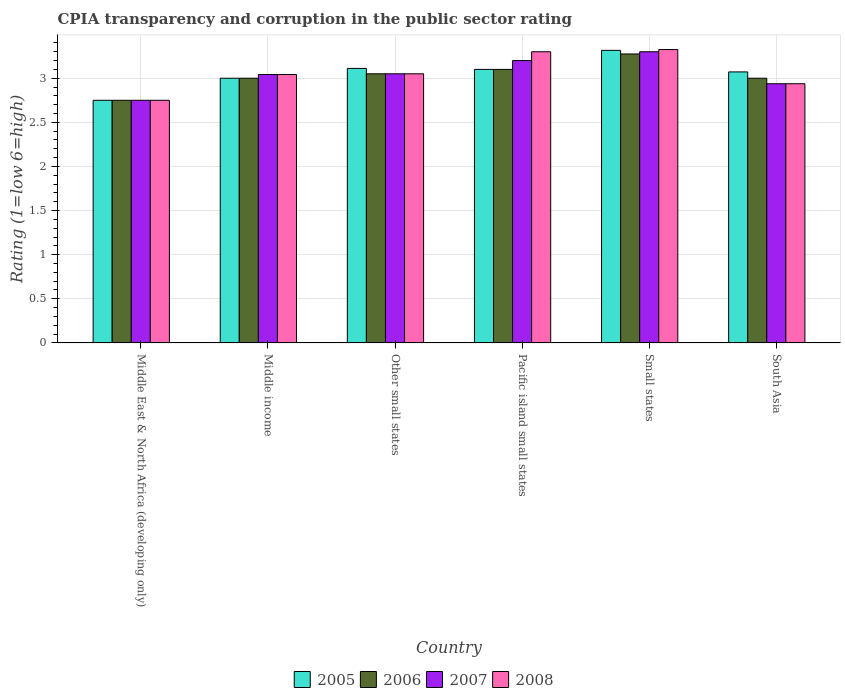Are the number of bars on each tick of the X-axis equal?
Offer a terse response. Yes. How many bars are there on the 6th tick from the left?
Your answer should be compact. 4. What is the label of the 5th group of bars from the left?
Offer a terse response. Small states. In how many cases, is the number of bars for a given country not equal to the number of legend labels?
Give a very brief answer. 0. What is the CPIA rating in 2005 in Other small states?
Your response must be concise. 3.11. Across all countries, what is the maximum CPIA rating in 2008?
Your response must be concise. 3.33. Across all countries, what is the minimum CPIA rating in 2008?
Ensure brevity in your answer.  2.75. In which country was the CPIA rating in 2007 maximum?
Your answer should be very brief. Small states. In which country was the CPIA rating in 2008 minimum?
Offer a terse response. Middle East & North Africa (developing only). What is the total CPIA rating in 2005 in the graph?
Your answer should be compact. 18.35. What is the difference between the CPIA rating in 2007 in Small states and that in South Asia?
Ensure brevity in your answer.  0.36. What is the difference between the CPIA rating in 2008 in Middle East & North Africa (developing only) and the CPIA rating in 2007 in Other small states?
Your answer should be compact. -0.3. What is the average CPIA rating in 2005 per country?
Your response must be concise. 3.06. What is the difference between the CPIA rating of/in 2007 and CPIA rating of/in 2008 in Small states?
Offer a very short reply. -0.03. In how many countries, is the CPIA rating in 2008 greater than 1.7?
Your response must be concise. 6. What is the ratio of the CPIA rating in 2006 in Middle East & North Africa (developing only) to that in South Asia?
Make the answer very short. 0.92. What is the difference between the highest and the second highest CPIA rating in 2007?
Provide a succinct answer. -0.1. What is the difference between the highest and the lowest CPIA rating in 2005?
Your answer should be compact. 0.57. In how many countries, is the CPIA rating in 2007 greater than the average CPIA rating in 2007 taken over all countries?
Provide a succinct answer. 3. Is the sum of the CPIA rating in 2008 in Pacific island small states and South Asia greater than the maximum CPIA rating in 2007 across all countries?
Your response must be concise. Yes. Is it the case that in every country, the sum of the CPIA rating in 2006 and CPIA rating in 2005 is greater than the sum of CPIA rating in 2007 and CPIA rating in 2008?
Your response must be concise. No. What does the 3rd bar from the left in Pacific island small states represents?
Your answer should be very brief. 2007. Is it the case that in every country, the sum of the CPIA rating in 2006 and CPIA rating in 2005 is greater than the CPIA rating in 2008?
Provide a succinct answer. Yes. How many bars are there?
Provide a short and direct response. 24. Are all the bars in the graph horizontal?
Make the answer very short. No. Does the graph contain grids?
Keep it short and to the point. Yes. Where does the legend appear in the graph?
Your response must be concise. Bottom center. What is the title of the graph?
Give a very brief answer. CPIA transparency and corruption in the public sector rating. Does "2003" appear as one of the legend labels in the graph?
Offer a terse response. No. What is the label or title of the X-axis?
Provide a short and direct response. Country. What is the Rating (1=low 6=high) of 2005 in Middle East & North Africa (developing only)?
Offer a terse response. 2.75. What is the Rating (1=low 6=high) of 2006 in Middle East & North Africa (developing only)?
Provide a short and direct response. 2.75. What is the Rating (1=low 6=high) in 2007 in Middle East & North Africa (developing only)?
Your answer should be compact. 2.75. What is the Rating (1=low 6=high) in 2008 in Middle East & North Africa (developing only)?
Provide a succinct answer. 2.75. What is the Rating (1=low 6=high) of 2005 in Middle income?
Provide a short and direct response. 3. What is the Rating (1=low 6=high) in 2007 in Middle income?
Keep it short and to the point. 3.04. What is the Rating (1=low 6=high) in 2008 in Middle income?
Keep it short and to the point. 3.04. What is the Rating (1=low 6=high) in 2005 in Other small states?
Your answer should be compact. 3.11. What is the Rating (1=low 6=high) of 2006 in Other small states?
Ensure brevity in your answer.  3.05. What is the Rating (1=low 6=high) in 2007 in Other small states?
Give a very brief answer. 3.05. What is the Rating (1=low 6=high) of 2008 in Other small states?
Keep it short and to the point. 3.05. What is the Rating (1=low 6=high) in 2006 in Pacific island small states?
Make the answer very short. 3.1. What is the Rating (1=low 6=high) of 2007 in Pacific island small states?
Provide a succinct answer. 3.2. What is the Rating (1=low 6=high) of 2008 in Pacific island small states?
Your answer should be very brief. 3.3. What is the Rating (1=low 6=high) in 2005 in Small states?
Your answer should be compact. 3.32. What is the Rating (1=low 6=high) in 2006 in Small states?
Provide a succinct answer. 3.27. What is the Rating (1=low 6=high) in 2008 in Small states?
Offer a terse response. 3.33. What is the Rating (1=low 6=high) of 2005 in South Asia?
Provide a succinct answer. 3.07. What is the Rating (1=low 6=high) in 2006 in South Asia?
Offer a very short reply. 3. What is the Rating (1=low 6=high) in 2007 in South Asia?
Provide a short and direct response. 2.94. What is the Rating (1=low 6=high) in 2008 in South Asia?
Ensure brevity in your answer.  2.94. Across all countries, what is the maximum Rating (1=low 6=high) of 2005?
Your response must be concise. 3.32. Across all countries, what is the maximum Rating (1=low 6=high) of 2006?
Your answer should be very brief. 3.27. Across all countries, what is the maximum Rating (1=low 6=high) of 2007?
Provide a succinct answer. 3.3. Across all countries, what is the maximum Rating (1=low 6=high) in 2008?
Offer a terse response. 3.33. Across all countries, what is the minimum Rating (1=low 6=high) in 2005?
Offer a terse response. 2.75. Across all countries, what is the minimum Rating (1=low 6=high) in 2006?
Provide a short and direct response. 2.75. Across all countries, what is the minimum Rating (1=low 6=high) of 2007?
Your response must be concise. 2.75. Across all countries, what is the minimum Rating (1=low 6=high) of 2008?
Provide a short and direct response. 2.75. What is the total Rating (1=low 6=high) of 2005 in the graph?
Your answer should be compact. 18.35. What is the total Rating (1=low 6=high) in 2006 in the graph?
Offer a very short reply. 18.18. What is the total Rating (1=low 6=high) of 2007 in the graph?
Your response must be concise. 18.28. What is the total Rating (1=low 6=high) of 2008 in the graph?
Ensure brevity in your answer.  18.4. What is the difference between the Rating (1=low 6=high) in 2007 in Middle East & North Africa (developing only) and that in Middle income?
Make the answer very short. -0.29. What is the difference between the Rating (1=low 6=high) in 2008 in Middle East & North Africa (developing only) and that in Middle income?
Your answer should be compact. -0.29. What is the difference between the Rating (1=low 6=high) of 2005 in Middle East & North Africa (developing only) and that in Other small states?
Provide a succinct answer. -0.36. What is the difference between the Rating (1=low 6=high) in 2006 in Middle East & North Africa (developing only) and that in Other small states?
Provide a short and direct response. -0.3. What is the difference between the Rating (1=low 6=high) of 2008 in Middle East & North Africa (developing only) and that in Other small states?
Make the answer very short. -0.3. What is the difference between the Rating (1=low 6=high) in 2005 in Middle East & North Africa (developing only) and that in Pacific island small states?
Give a very brief answer. -0.35. What is the difference between the Rating (1=low 6=high) of 2006 in Middle East & North Africa (developing only) and that in Pacific island small states?
Your answer should be compact. -0.35. What is the difference between the Rating (1=low 6=high) in 2007 in Middle East & North Africa (developing only) and that in Pacific island small states?
Give a very brief answer. -0.45. What is the difference between the Rating (1=low 6=high) in 2008 in Middle East & North Africa (developing only) and that in Pacific island small states?
Provide a succinct answer. -0.55. What is the difference between the Rating (1=low 6=high) of 2005 in Middle East & North Africa (developing only) and that in Small states?
Your response must be concise. -0.57. What is the difference between the Rating (1=low 6=high) in 2006 in Middle East & North Africa (developing only) and that in Small states?
Make the answer very short. -0.53. What is the difference between the Rating (1=low 6=high) of 2007 in Middle East & North Africa (developing only) and that in Small states?
Ensure brevity in your answer.  -0.55. What is the difference between the Rating (1=low 6=high) of 2008 in Middle East & North Africa (developing only) and that in Small states?
Your answer should be compact. -0.57. What is the difference between the Rating (1=low 6=high) in 2005 in Middle East & North Africa (developing only) and that in South Asia?
Your answer should be very brief. -0.32. What is the difference between the Rating (1=low 6=high) of 2007 in Middle East & North Africa (developing only) and that in South Asia?
Give a very brief answer. -0.19. What is the difference between the Rating (1=low 6=high) in 2008 in Middle East & North Africa (developing only) and that in South Asia?
Ensure brevity in your answer.  -0.19. What is the difference between the Rating (1=low 6=high) in 2005 in Middle income and that in Other small states?
Your answer should be compact. -0.11. What is the difference between the Rating (1=low 6=high) of 2006 in Middle income and that in Other small states?
Your answer should be very brief. -0.05. What is the difference between the Rating (1=low 6=high) in 2007 in Middle income and that in Other small states?
Ensure brevity in your answer.  -0.01. What is the difference between the Rating (1=low 6=high) in 2008 in Middle income and that in Other small states?
Your answer should be very brief. -0.01. What is the difference between the Rating (1=low 6=high) of 2005 in Middle income and that in Pacific island small states?
Provide a succinct answer. -0.1. What is the difference between the Rating (1=low 6=high) in 2006 in Middle income and that in Pacific island small states?
Provide a short and direct response. -0.1. What is the difference between the Rating (1=low 6=high) in 2007 in Middle income and that in Pacific island small states?
Offer a terse response. -0.16. What is the difference between the Rating (1=low 6=high) of 2008 in Middle income and that in Pacific island small states?
Provide a short and direct response. -0.26. What is the difference between the Rating (1=low 6=high) of 2005 in Middle income and that in Small states?
Provide a succinct answer. -0.32. What is the difference between the Rating (1=low 6=high) of 2006 in Middle income and that in Small states?
Give a very brief answer. -0.28. What is the difference between the Rating (1=low 6=high) of 2007 in Middle income and that in Small states?
Provide a succinct answer. -0.26. What is the difference between the Rating (1=low 6=high) in 2008 in Middle income and that in Small states?
Provide a short and direct response. -0.28. What is the difference between the Rating (1=low 6=high) of 2005 in Middle income and that in South Asia?
Provide a short and direct response. -0.07. What is the difference between the Rating (1=low 6=high) in 2007 in Middle income and that in South Asia?
Keep it short and to the point. 0.1. What is the difference between the Rating (1=low 6=high) of 2008 in Middle income and that in South Asia?
Keep it short and to the point. 0.1. What is the difference between the Rating (1=low 6=high) of 2005 in Other small states and that in Pacific island small states?
Ensure brevity in your answer.  0.01. What is the difference between the Rating (1=low 6=high) in 2005 in Other small states and that in Small states?
Keep it short and to the point. -0.2. What is the difference between the Rating (1=low 6=high) of 2006 in Other small states and that in Small states?
Provide a short and direct response. -0.23. What is the difference between the Rating (1=low 6=high) in 2007 in Other small states and that in Small states?
Your answer should be compact. -0.25. What is the difference between the Rating (1=low 6=high) in 2008 in Other small states and that in Small states?
Your response must be concise. -0.28. What is the difference between the Rating (1=low 6=high) of 2005 in Other small states and that in South Asia?
Make the answer very short. 0.04. What is the difference between the Rating (1=low 6=high) in 2007 in Other small states and that in South Asia?
Provide a short and direct response. 0.11. What is the difference between the Rating (1=low 6=high) in 2008 in Other small states and that in South Asia?
Give a very brief answer. 0.11. What is the difference between the Rating (1=low 6=high) of 2005 in Pacific island small states and that in Small states?
Give a very brief answer. -0.22. What is the difference between the Rating (1=low 6=high) of 2006 in Pacific island small states and that in Small states?
Give a very brief answer. -0.17. What is the difference between the Rating (1=low 6=high) of 2007 in Pacific island small states and that in Small states?
Make the answer very short. -0.1. What is the difference between the Rating (1=low 6=high) in 2008 in Pacific island small states and that in Small states?
Keep it short and to the point. -0.03. What is the difference between the Rating (1=low 6=high) of 2005 in Pacific island small states and that in South Asia?
Offer a very short reply. 0.03. What is the difference between the Rating (1=low 6=high) in 2007 in Pacific island small states and that in South Asia?
Ensure brevity in your answer.  0.26. What is the difference between the Rating (1=low 6=high) in 2008 in Pacific island small states and that in South Asia?
Offer a terse response. 0.36. What is the difference between the Rating (1=low 6=high) of 2005 in Small states and that in South Asia?
Ensure brevity in your answer.  0.24. What is the difference between the Rating (1=low 6=high) of 2006 in Small states and that in South Asia?
Your answer should be very brief. 0.28. What is the difference between the Rating (1=low 6=high) in 2007 in Small states and that in South Asia?
Keep it short and to the point. 0.36. What is the difference between the Rating (1=low 6=high) in 2008 in Small states and that in South Asia?
Your answer should be very brief. 0.39. What is the difference between the Rating (1=low 6=high) of 2005 in Middle East & North Africa (developing only) and the Rating (1=low 6=high) of 2006 in Middle income?
Your response must be concise. -0.25. What is the difference between the Rating (1=low 6=high) of 2005 in Middle East & North Africa (developing only) and the Rating (1=low 6=high) of 2007 in Middle income?
Make the answer very short. -0.29. What is the difference between the Rating (1=low 6=high) of 2005 in Middle East & North Africa (developing only) and the Rating (1=low 6=high) of 2008 in Middle income?
Your answer should be very brief. -0.29. What is the difference between the Rating (1=low 6=high) in 2006 in Middle East & North Africa (developing only) and the Rating (1=low 6=high) in 2007 in Middle income?
Offer a very short reply. -0.29. What is the difference between the Rating (1=low 6=high) of 2006 in Middle East & North Africa (developing only) and the Rating (1=low 6=high) of 2008 in Middle income?
Offer a terse response. -0.29. What is the difference between the Rating (1=low 6=high) in 2007 in Middle East & North Africa (developing only) and the Rating (1=low 6=high) in 2008 in Middle income?
Give a very brief answer. -0.29. What is the difference between the Rating (1=low 6=high) of 2005 in Middle East & North Africa (developing only) and the Rating (1=low 6=high) of 2008 in Other small states?
Provide a short and direct response. -0.3. What is the difference between the Rating (1=low 6=high) in 2006 in Middle East & North Africa (developing only) and the Rating (1=low 6=high) in 2007 in Other small states?
Your response must be concise. -0.3. What is the difference between the Rating (1=low 6=high) of 2005 in Middle East & North Africa (developing only) and the Rating (1=low 6=high) of 2006 in Pacific island small states?
Make the answer very short. -0.35. What is the difference between the Rating (1=low 6=high) in 2005 in Middle East & North Africa (developing only) and the Rating (1=low 6=high) in 2007 in Pacific island small states?
Keep it short and to the point. -0.45. What is the difference between the Rating (1=low 6=high) in 2005 in Middle East & North Africa (developing only) and the Rating (1=low 6=high) in 2008 in Pacific island small states?
Keep it short and to the point. -0.55. What is the difference between the Rating (1=low 6=high) of 2006 in Middle East & North Africa (developing only) and the Rating (1=low 6=high) of 2007 in Pacific island small states?
Offer a terse response. -0.45. What is the difference between the Rating (1=low 6=high) of 2006 in Middle East & North Africa (developing only) and the Rating (1=low 6=high) of 2008 in Pacific island small states?
Your response must be concise. -0.55. What is the difference between the Rating (1=low 6=high) of 2007 in Middle East & North Africa (developing only) and the Rating (1=low 6=high) of 2008 in Pacific island small states?
Your answer should be very brief. -0.55. What is the difference between the Rating (1=low 6=high) in 2005 in Middle East & North Africa (developing only) and the Rating (1=low 6=high) in 2006 in Small states?
Make the answer very short. -0.53. What is the difference between the Rating (1=low 6=high) in 2005 in Middle East & North Africa (developing only) and the Rating (1=low 6=high) in 2007 in Small states?
Offer a very short reply. -0.55. What is the difference between the Rating (1=low 6=high) of 2005 in Middle East & North Africa (developing only) and the Rating (1=low 6=high) of 2008 in Small states?
Offer a terse response. -0.57. What is the difference between the Rating (1=low 6=high) in 2006 in Middle East & North Africa (developing only) and the Rating (1=low 6=high) in 2007 in Small states?
Provide a succinct answer. -0.55. What is the difference between the Rating (1=low 6=high) of 2006 in Middle East & North Africa (developing only) and the Rating (1=low 6=high) of 2008 in Small states?
Offer a very short reply. -0.57. What is the difference between the Rating (1=low 6=high) in 2007 in Middle East & North Africa (developing only) and the Rating (1=low 6=high) in 2008 in Small states?
Provide a short and direct response. -0.57. What is the difference between the Rating (1=low 6=high) in 2005 in Middle East & North Africa (developing only) and the Rating (1=low 6=high) in 2006 in South Asia?
Provide a short and direct response. -0.25. What is the difference between the Rating (1=low 6=high) of 2005 in Middle East & North Africa (developing only) and the Rating (1=low 6=high) of 2007 in South Asia?
Your answer should be compact. -0.19. What is the difference between the Rating (1=low 6=high) of 2005 in Middle East & North Africa (developing only) and the Rating (1=low 6=high) of 2008 in South Asia?
Offer a terse response. -0.19. What is the difference between the Rating (1=low 6=high) in 2006 in Middle East & North Africa (developing only) and the Rating (1=low 6=high) in 2007 in South Asia?
Offer a terse response. -0.19. What is the difference between the Rating (1=low 6=high) in 2006 in Middle East & North Africa (developing only) and the Rating (1=low 6=high) in 2008 in South Asia?
Your answer should be very brief. -0.19. What is the difference between the Rating (1=low 6=high) of 2007 in Middle East & North Africa (developing only) and the Rating (1=low 6=high) of 2008 in South Asia?
Make the answer very short. -0.19. What is the difference between the Rating (1=low 6=high) of 2005 in Middle income and the Rating (1=low 6=high) of 2007 in Other small states?
Make the answer very short. -0.05. What is the difference between the Rating (1=low 6=high) in 2005 in Middle income and the Rating (1=low 6=high) in 2008 in Other small states?
Offer a very short reply. -0.05. What is the difference between the Rating (1=low 6=high) of 2006 in Middle income and the Rating (1=low 6=high) of 2007 in Other small states?
Your answer should be compact. -0.05. What is the difference between the Rating (1=low 6=high) of 2007 in Middle income and the Rating (1=low 6=high) of 2008 in Other small states?
Ensure brevity in your answer.  -0.01. What is the difference between the Rating (1=low 6=high) of 2007 in Middle income and the Rating (1=low 6=high) of 2008 in Pacific island small states?
Make the answer very short. -0.26. What is the difference between the Rating (1=low 6=high) of 2005 in Middle income and the Rating (1=low 6=high) of 2006 in Small states?
Make the answer very short. -0.28. What is the difference between the Rating (1=low 6=high) in 2005 in Middle income and the Rating (1=low 6=high) in 2008 in Small states?
Provide a succinct answer. -0.33. What is the difference between the Rating (1=low 6=high) of 2006 in Middle income and the Rating (1=low 6=high) of 2007 in Small states?
Your response must be concise. -0.3. What is the difference between the Rating (1=low 6=high) of 2006 in Middle income and the Rating (1=low 6=high) of 2008 in Small states?
Provide a succinct answer. -0.33. What is the difference between the Rating (1=low 6=high) of 2007 in Middle income and the Rating (1=low 6=high) of 2008 in Small states?
Provide a succinct answer. -0.28. What is the difference between the Rating (1=low 6=high) of 2005 in Middle income and the Rating (1=low 6=high) of 2007 in South Asia?
Give a very brief answer. 0.06. What is the difference between the Rating (1=low 6=high) in 2005 in Middle income and the Rating (1=low 6=high) in 2008 in South Asia?
Keep it short and to the point. 0.06. What is the difference between the Rating (1=low 6=high) of 2006 in Middle income and the Rating (1=low 6=high) of 2007 in South Asia?
Offer a terse response. 0.06. What is the difference between the Rating (1=low 6=high) of 2006 in Middle income and the Rating (1=low 6=high) of 2008 in South Asia?
Make the answer very short. 0.06. What is the difference between the Rating (1=low 6=high) in 2007 in Middle income and the Rating (1=low 6=high) in 2008 in South Asia?
Give a very brief answer. 0.1. What is the difference between the Rating (1=low 6=high) in 2005 in Other small states and the Rating (1=low 6=high) in 2006 in Pacific island small states?
Keep it short and to the point. 0.01. What is the difference between the Rating (1=low 6=high) in 2005 in Other small states and the Rating (1=low 6=high) in 2007 in Pacific island small states?
Provide a succinct answer. -0.09. What is the difference between the Rating (1=low 6=high) in 2005 in Other small states and the Rating (1=low 6=high) in 2008 in Pacific island small states?
Your answer should be very brief. -0.19. What is the difference between the Rating (1=low 6=high) in 2006 in Other small states and the Rating (1=low 6=high) in 2007 in Pacific island small states?
Your answer should be very brief. -0.15. What is the difference between the Rating (1=low 6=high) in 2006 in Other small states and the Rating (1=low 6=high) in 2008 in Pacific island small states?
Offer a terse response. -0.25. What is the difference between the Rating (1=low 6=high) in 2007 in Other small states and the Rating (1=low 6=high) in 2008 in Pacific island small states?
Your response must be concise. -0.25. What is the difference between the Rating (1=low 6=high) of 2005 in Other small states and the Rating (1=low 6=high) of 2006 in Small states?
Make the answer very short. -0.16. What is the difference between the Rating (1=low 6=high) of 2005 in Other small states and the Rating (1=low 6=high) of 2007 in Small states?
Ensure brevity in your answer.  -0.19. What is the difference between the Rating (1=low 6=high) of 2005 in Other small states and the Rating (1=low 6=high) of 2008 in Small states?
Ensure brevity in your answer.  -0.21. What is the difference between the Rating (1=low 6=high) in 2006 in Other small states and the Rating (1=low 6=high) in 2008 in Small states?
Ensure brevity in your answer.  -0.28. What is the difference between the Rating (1=low 6=high) of 2007 in Other small states and the Rating (1=low 6=high) of 2008 in Small states?
Your answer should be compact. -0.28. What is the difference between the Rating (1=low 6=high) of 2005 in Other small states and the Rating (1=low 6=high) of 2007 in South Asia?
Provide a succinct answer. 0.17. What is the difference between the Rating (1=low 6=high) in 2005 in Other small states and the Rating (1=low 6=high) in 2008 in South Asia?
Provide a succinct answer. 0.17. What is the difference between the Rating (1=low 6=high) in 2006 in Other small states and the Rating (1=low 6=high) in 2007 in South Asia?
Make the answer very short. 0.11. What is the difference between the Rating (1=low 6=high) in 2006 in Other small states and the Rating (1=low 6=high) in 2008 in South Asia?
Your response must be concise. 0.11. What is the difference between the Rating (1=low 6=high) in 2007 in Other small states and the Rating (1=low 6=high) in 2008 in South Asia?
Ensure brevity in your answer.  0.11. What is the difference between the Rating (1=low 6=high) of 2005 in Pacific island small states and the Rating (1=low 6=high) of 2006 in Small states?
Offer a very short reply. -0.17. What is the difference between the Rating (1=low 6=high) of 2005 in Pacific island small states and the Rating (1=low 6=high) of 2007 in Small states?
Provide a short and direct response. -0.2. What is the difference between the Rating (1=low 6=high) of 2005 in Pacific island small states and the Rating (1=low 6=high) of 2008 in Small states?
Make the answer very short. -0.23. What is the difference between the Rating (1=low 6=high) in 2006 in Pacific island small states and the Rating (1=low 6=high) in 2008 in Small states?
Your response must be concise. -0.23. What is the difference between the Rating (1=low 6=high) of 2007 in Pacific island small states and the Rating (1=low 6=high) of 2008 in Small states?
Ensure brevity in your answer.  -0.12. What is the difference between the Rating (1=low 6=high) in 2005 in Pacific island small states and the Rating (1=low 6=high) in 2007 in South Asia?
Give a very brief answer. 0.16. What is the difference between the Rating (1=low 6=high) in 2005 in Pacific island small states and the Rating (1=low 6=high) in 2008 in South Asia?
Offer a very short reply. 0.16. What is the difference between the Rating (1=low 6=high) of 2006 in Pacific island small states and the Rating (1=low 6=high) of 2007 in South Asia?
Give a very brief answer. 0.16. What is the difference between the Rating (1=low 6=high) in 2006 in Pacific island small states and the Rating (1=low 6=high) in 2008 in South Asia?
Offer a terse response. 0.16. What is the difference between the Rating (1=low 6=high) of 2007 in Pacific island small states and the Rating (1=low 6=high) of 2008 in South Asia?
Offer a very short reply. 0.26. What is the difference between the Rating (1=low 6=high) of 2005 in Small states and the Rating (1=low 6=high) of 2006 in South Asia?
Make the answer very short. 0.32. What is the difference between the Rating (1=low 6=high) in 2005 in Small states and the Rating (1=low 6=high) in 2007 in South Asia?
Your answer should be very brief. 0.38. What is the difference between the Rating (1=low 6=high) in 2005 in Small states and the Rating (1=low 6=high) in 2008 in South Asia?
Give a very brief answer. 0.38. What is the difference between the Rating (1=low 6=high) in 2006 in Small states and the Rating (1=low 6=high) in 2007 in South Asia?
Your answer should be compact. 0.34. What is the difference between the Rating (1=low 6=high) in 2006 in Small states and the Rating (1=low 6=high) in 2008 in South Asia?
Offer a very short reply. 0.34. What is the difference between the Rating (1=low 6=high) in 2007 in Small states and the Rating (1=low 6=high) in 2008 in South Asia?
Keep it short and to the point. 0.36. What is the average Rating (1=low 6=high) of 2005 per country?
Your response must be concise. 3.06. What is the average Rating (1=low 6=high) of 2006 per country?
Provide a succinct answer. 3.03. What is the average Rating (1=low 6=high) in 2007 per country?
Your response must be concise. 3.05. What is the average Rating (1=low 6=high) of 2008 per country?
Provide a succinct answer. 3.07. What is the difference between the Rating (1=low 6=high) of 2005 and Rating (1=low 6=high) of 2008 in Middle East & North Africa (developing only)?
Give a very brief answer. 0. What is the difference between the Rating (1=low 6=high) in 2006 and Rating (1=low 6=high) in 2007 in Middle East & North Africa (developing only)?
Make the answer very short. 0. What is the difference between the Rating (1=low 6=high) of 2007 and Rating (1=low 6=high) of 2008 in Middle East & North Africa (developing only)?
Your response must be concise. 0. What is the difference between the Rating (1=low 6=high) of 2005 and Rating (1=low 6=high) of 2006 in Middle income?
Provide a short and direct response. 0. What is the difference between the Rating (1=low 6=high) of 2005 and Rating (1=low 6=high) of 2007 in Middle income?
Make the answer very short. -0.04. What is the difference between the Rating (1=low 6=high) of 2005 and Rating (1=low 6=high) of 2008 in Middle income?
Keep it short and to the point. -0.04. What is the difference between the Rating (1=low 6=high) in 2006 and Rating (1=low 6=high) in 2007 in Middle income?
Your answer should be compact. -0.04. What is the difference between the Rating (1=low 6=high) in 2006 and Rating (1=low 6=high) in 2008 in Middle income?
Offer a terse response. -0.04. What is the difference between the Rating (1=low 6=high) of 2007 and Rating (1=low 6=high) of 2008 in Middle income?
Give a very brief answer. 0. What is the difference between the Rating (1=low 6=high) of 2005 and Rating (1=low 6=high) of 2006 in Other small states?
Offer a terse response. 0.06. What is the difference between the Rating (1=low 6=high) of 2005 and Rating (1=low 6=high) of 2007 in Other small states?
Provide a short and direct response. 0.06. What is the difference between the Rating (1=low 6=high) of 2005 and Rating (1=low 6=high) of 2008 in Other small states?
Your answer should be compact. 0.06. What is the difference between the Rating (1=low 6=high) in 2006 and Rating (1=low 6=high) in 2007 in Other small states?
Ensure brevity in your answer.  0. What is the difference between the Rating (1=low 6=high) in 2006 and Rating (1=low 6=high) in 2008 in Other small states?
Keep it short and to the point. 0. What is the difference between the Rating (1=low 6=high) of 2005 and Rating (1=low 6=high) of 2006 in Pacific island small states?
Your response must be concise. 0. What is the difference between the Rating (1=low 6=high) of 2005 and Rating (1=low 6=high) of 2008 in Pacific island small states?
Make the answer very short. -0.2. What is the difference between the Rating (1=low 6=high) of 2006 and Rating (1=low 6=high) of 2008 in Pacific island small states?
Offer a very short reply. -0.2. What is the difference between the Rating (1=low 6=high) in 2007 and Rating (1=low 6=high) in 2008 in Pacific island small states?
Offer a very short reply. -0.1. What is the difference between the Rating (1=low 6=high) in 2005 and Rating (1=low 6=high) in 2006 in Small states?
Ensure brevity in your answer.  0.04. What is the difference between the Rating (1=low 6=high) of 2005 and Rating (1=low 6=high) of 2007 in Small states?
Your response must be concise. 0.02. What is the difference between the Rating (1=low 6=high) of 2005 and Rating (1=low 6=high) of 2008 in Small states?
Offer a terse response. -0.01. What is the difference between the Rating (1=low 6=high) of 2006 and Rating (1=low 6=high) of 2007 in Small states?
Your response must be concise. -0.03. What is the difference between the Rating (1=low 6=high) in 2006 and Rating (1=low 6=high) in 2008 in Small states?
Ensure brevity in your answer.  -0.05. What is the difference between the Rating (1=low 6=high) in 2007 and Rating (1=low 6=high) in 2008 in Small states?
Keep it short and to the point. -0.03. What is the difference between the Rating (1=low 6=high) of 2005 and Rating (1=low 6=high) of 2006 in South Asia?
Make the answer very short. 0.07. What is the difference between the Rating (1=low 6=high) in 2005 and Rating (1=low 6=high) in 2007 in South Asia?
Your response must be concise. 0.13. What is the difference between the Rating (1=low 6=high) in 2005 and Rating (1=low 6=high) in 2008 in South Asia?
Your answer should be compact. 0.13. What is the difference between the Rating (1=low 6=high) in 2006 and Rating (1=low 6=high) in 2007 in South Asia?
Make the answer very short. 0.06. What is the difference between the Rating (1=low 6=high) of 2006 and Rating (1=low 6=high) of 2008 in South Asia?
Ensure brevity in your answer.  0.06. What is the difference between the Rating (1=low 6=high) in 2007 and Rating (1=low 6=high) in 2008 in South Asia?
Offer a terse response. 0. What is the ratio of the Rating (1=low 6=high) in 2005 in Middle East & North Africa (developing only) to that in Middle income?
Give a very brief answer. 0.92. What is the ratio of the Rating (1=low 6=high) of 2007 in Middle East & North Africa (developing only) to that in Middle income?
Your answer should be very brief. 0.9. What is the ratio of the Rating (1=low 6=high) of 2008 in Middle East & North Africa (developing only) to that in Middle income?
Keep it short and to the point. 0.9. What is the ratio of the Rating (1=low 6=high) in 2005 in Middle East & North Africa (developing only) to that in Other small states?
Your response must be concise. 0.88. What is the ratio of the Rating (1=low 6=high) of 2006 in Middle East & North Africa (developing only) to that in Other small states?
Offer a very short reply. 0.9. What is the ratio of the Rating (1=low 6=high) of 2007 in Middle East & North Africa (developing only) to that in Other small states?
Your answer should be very brief. 0.9. What is the ratio of the Rating (1=low 6=high) in 2008 in Middle East & North Africa (developing only) to that in Other small states?
Offer a terse response. 0.9. What is the ratio of the Rating (1=low 6=high) of 2005 in Middle East & North Africa (developing only) to that in Pacific island small states?
Your answer should be compact. 0.89. What is the ratio of the Rating (1=low 6=high) of 2006 in Middle East & North Africa (developing only) to that in Pacific island small states?
Your answer should be compact. 0.89. What is the ratio of the Rating (1=low 6=high) in 2007 in Middle East & North Africa (developing only) to that in Pacific island small states?
Provide a short and direct response. 0.86. What is the ratio of the Rating (1=low 6=high) of 2005 in Middle East & North Africa (developing only) to that in Small states?
Make the answer very short. 0.83. What is the ratio of the Rating (1=low 6=high) in 2006 in Middle East & North Africa (developing only) to that in Small states?
Your response must be concise. 0.84. What is the ratio of the Rating (1=low 6=high) in 2007 in Middle East & North Africa (developing only) to that in Small states?
Offer a very short reply. 0.83. What is the ratio of the Rating (1=low 6=high) in 2008 in Middle East & North Africa (developing only) to that in Small states?
Offer a terse response. 0.83. What is the ratio of the Rating (1=low 6=high) of 2005 in Middle East & North Africa (developing only) to that in South Asia?
Your response must be concise. 0.9. What is the ratio of the Rating (1=low 6=high) in 2007 in Middle East & North Africa (developing only) to that in South Asia?
Give a very brief answer. 0.94. What is the ratio of the Rating (1=low 6=high) of 2008 in Middle East & North Africa (developing only) to that in South Asia?
Give a very brief answer. 0.94. What is the ratio of the Rating (1=low 6=high) of 2006 in Middle income to that in Other small states?
Provide a short and direct response. 0.98. What is the ratio of the Rating (1=low 6=high) in 2007 in Middle income to that in Other small states?
Provide a short and direct response. 1. What is the ratio of the Rating (1=low 6=high) in 2008 in Middle income to that in Other small states?
Provide a short and direct response. 1. What is the ratio of the Rating (1=low 6=high) in 2006 in Middle income to that in Pacific island small states?
Give a very brief answer. 0.97. What is the ratio of the Rating (1=low 6=high) in 2007 in Middle income to that in Pacific island small states?
Provide a short and direct response. 0.95. What is the ratio of the Rating (1=low 6=high) in 2008 in Middle income to that in Pacific island small states?
Your response must be concise. 0.92. What is the ratio of the Rating (1=low 6=high) in 2005 in Middle income to that in Small states?
Provide a short and direct response. 0.9. What is the ratio of the Rating (1=low 6=high) in 2006 in Middle income to that in Small states?
Provide a short and direct response. 0.92. What is the ratio of the Rating (1=low 6=high) in 2007 in Middle income to that in Small states?
Your response must be concise. 0.92. What is the ratio of the Rating (1=low 6=high) in 2008 in Middle income to that in Small states?
Keep it short and to the point. 0.91. What is the ratio of the Rating (1=low 6=high) in 2005 in Middle income to that in South Asia?
Provide a short and direct response. 0.98. What is the ratio of the Rating (1=low 6=high) of 2006 in Middle income to that in South Asia?
Your answer should be very brief. 1. What is the ratio of the Rating (1=low 6=high) in 2007 in Middle income to that in South Asia?
Provide a succinct answer. 1.04. What is the ratio of the Rating (1=low 6=high) of 2008 in Middle income to that in South Asia?
Keep it short and to the point. 1.04. What is the ratio of the Rating (1=low 6=high) in 2006 in Other small states to that in Pacific island small states?
Make the answer very short. 0.98. What is the ratio of the Rating (1=low 6=high) of 2007 in Other small states to that in Pacific island small states?
Your answer should be compact. 0.95. What is the ratio of the Rating (1=low 6=high) in 2008 in Other small states to that in Pacific island small states?
Your answer should be compact. 0.92. What is the ratio of the Rating (1=low 6=high) in 2005 in Other small states to that in Small states?
Make the answer very short. 0.94. What is the ratio of the Rating (1=low 6=high) in 2006 in Other small states to that in Small states?
Make the answer very short. 0.93. What is the ratio of the Rating (1=low 6=high) of 2007 in Other small states to that in Small states?
Offer a terse response. 0.92. What is the ratio of the Rating (1=low 6=high) of 2008 in Other small states to that in Small states?
Your answer should be compact. 0.92. What is the ratio of the Rating (1=low 6=high) in 2005 in Other small states to that in South Asia?
Provide a short and direct response. 1.01. What is the ratio of the Rating (1=low 6=high) of 2006 in Other small states to that in South Asia?
Your answer should be compact. 1.02. What is the ratio of the Rating (1=low 6=high) in 2007 in Other small states to that in South Asia?
Your response must be concise. 1.04. What is the ratio of the Rating (1=low 6=high) in 2008 in Other small states to that in South Asia?
Offer a very short reply. 1.04. What is the ratio of the Rating (1=low 6=high) of 2005 in Pacific island small states to that in Small states?
Keep it short and to the point. 0.93. What is the ratio of the Rating (1=low 6=high) of 2006 in Pacific island small states to that in Small states?
Give a very brief answer. 0.95. What is the ratio of the Rating (1=low 6=high) in 2007 in Pacific island small states to that in Small states?
Your response must be concise. 0.97. What is the ratio of the Rating (1=low 6=high) in 2005 in Pacific island small states to that in South Asia?
Provide a succinct answer. 1.01. What is the ratio of the Rating (1=low 6=high) in 2007 in Pacific island small states to that in South Asia?
Your answer should be compact. 1.09. What is the ratio of the Rating (1=low 6=high) of 2008 in Pacific island small states to that in South Asia?
Make the answer very short. 1.12. What is the ratio of the Rating (1=low 6=high) in 2005 in Small states to that in South Asia?
Make the answer very short. 1.08. What is the ratio of the Rating (1=low 6=high) of 2006 in Small states to that in South Asia?
Provide a succinct answer. 1.09. What is the ratio of the Rating (1=low 6=high) in 2007 in Small states to that in South Asia?
Keep it short and to the point. 1.12. What is the ratio of the Rating (1=low 6=high) of 2008 in Small states to that in South Asia?
Give a very brief answer. 1.13. What is the difference between the highest and the second highest Rating (1=low 6=high) of 2005?
Your response must be concise. 0.2. What is the difference between the highest and the second highest Rating (1=low 6=high) of 2006?
Your answer should be very brief. 0.17. What is the difference between the highest and the second highest Rating (1=low 6=high) of 2007?
Give a very brief answer. 0.1. What is the difference between the highest and the second highest Rating (1=low 6=high) of 2008?
Your response must be concise. 0.03. What is the difference between the highest and the lowest Rating (1=low 6=high) in 2005?
Your response must be concise. 0.57. What is the difference between the highest and the lowest Rating (1=low 6=high) of 2006?
Provide a short and direct response. 0.53. What is the difference between the highest and the lowest Rating (1=low 6=high) of 2007?
Your answer should be very brief. 0.55. What is the difference between the highest and the lowest Rating (1=low 6=high) of 2008?
Keep it short and to the point. 0.57. 